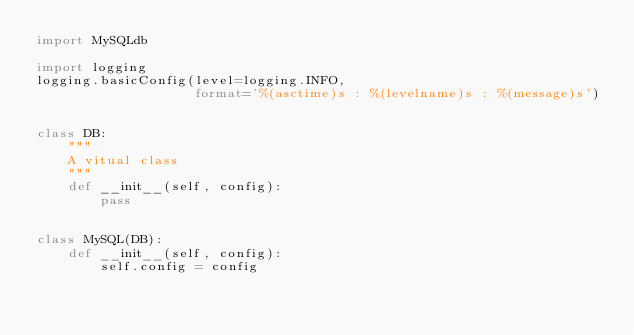<code> <loc_0><loc_0><loc_500><loc_500><_Python_>import MySQLdb

import logging
logging.basicConfig(level=logging.INFO,
                    format='%(asctime)s : %(levelname)s : %(message)s')


class DB:
    """
    A vitual class
    """
    def __init__(self, config):
        pass


class MySQL(DB):
    def __init__(self, config):
        self.config = config</code> 